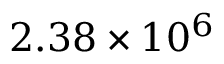<formula> <loc_0><loc_0><loc_500><loc_500>2 . 3 8 \times 1 0 ^ { 6 }</formula> 